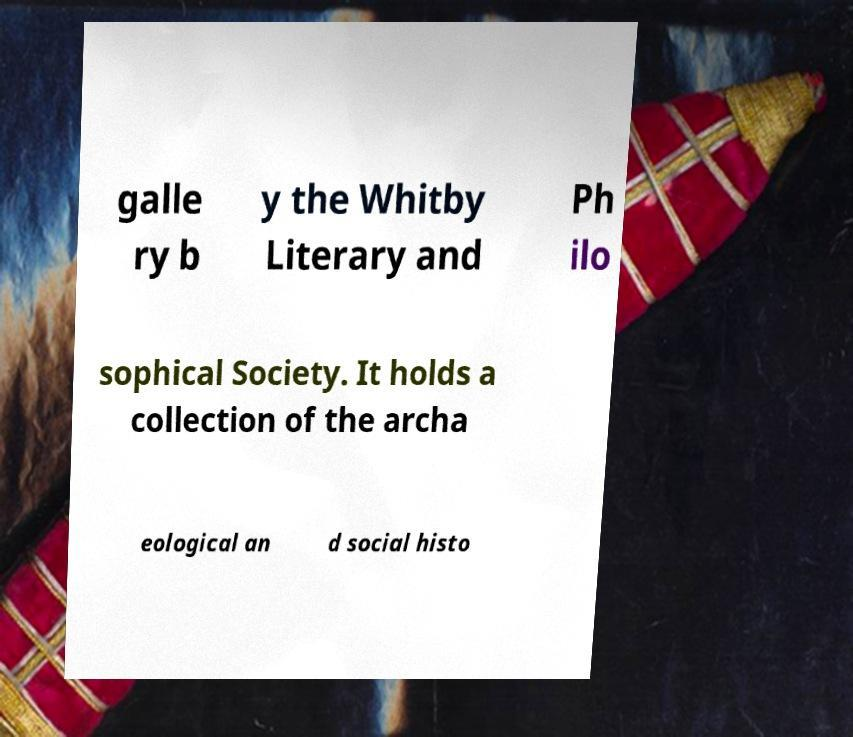Can you read and provide the text displayed in the image?This photo seems to have some interesting text. Can you extract and type it out for me? galle ry b y the Whitby Literary and Ph ilo sophical Society. It holds a collection of the archa eological an d social histo 